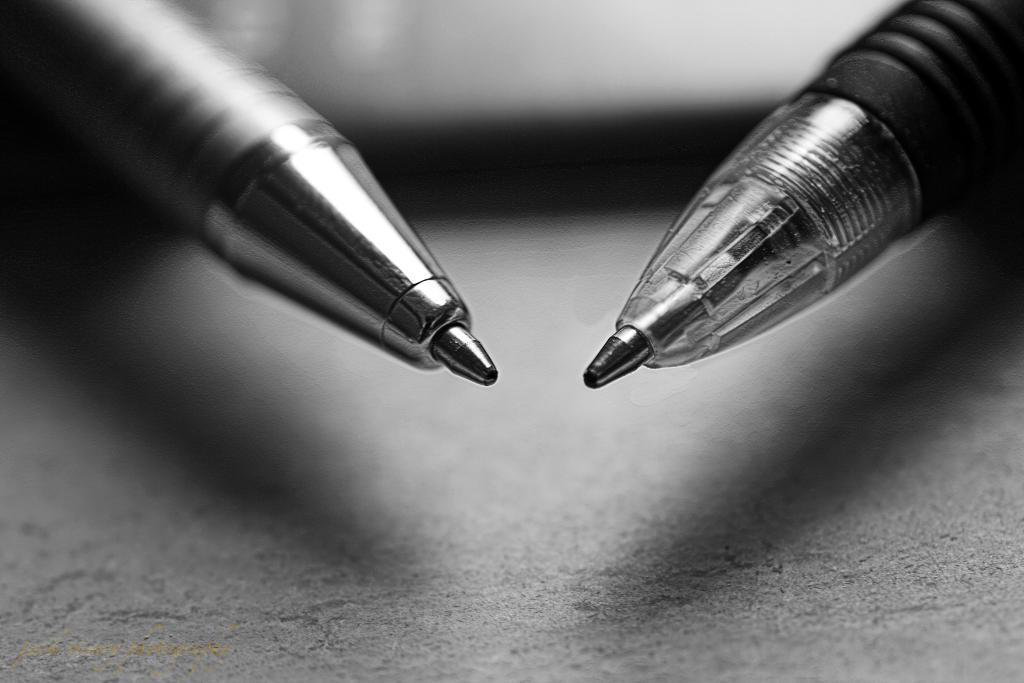Could you give a brief overview of what you see in this image? In this image these are pens and the background is blurry. 